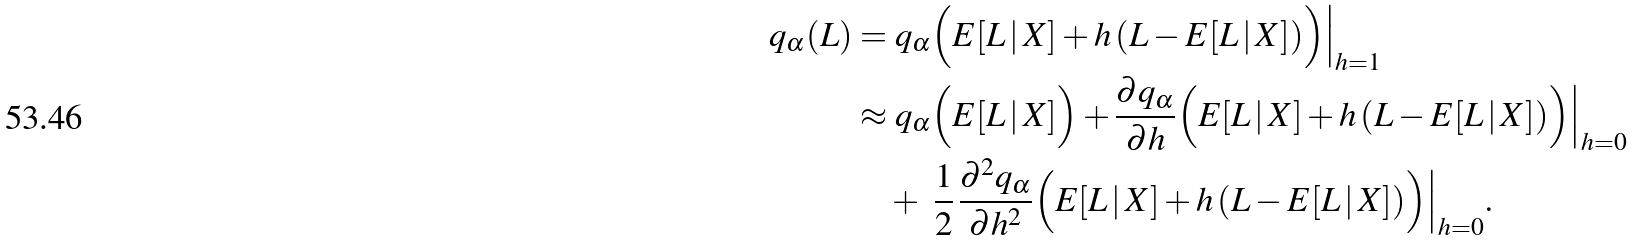Convert formula to latex. <formula><loc_0><loc_0><loc_500><loc_500>q _ { \alpha } ( L ) & = q _ { \alpha } \Big ( E [ L \, | \, X ] + h \, ( L - E [ L \, | \, X ] ) \Big ) \Big | _ { h = 1 } \\ & \approx q _ { \alpha } \Big ( E [ L \, | \, X ] \Big ) + \frac { \partial q _ { \alpha } } { \partial h } \Big ( E [ L \, | \, X ] + h \, ( L - E [ L \, | \, X ] ) \Big ) \Big | _ { h = 0 } \\ & \quad + \ \frac { 1 } { 2 } \, \frac { \partial ^ { 2 } q _ { \alpha } } { \partial h ^ { 2 } } \Big ( E [ L \, | \, X ] + h \, ( L - E [ L \, | \, X ] ) \Big ) \Big | _ { h = 0 } .</formula> 